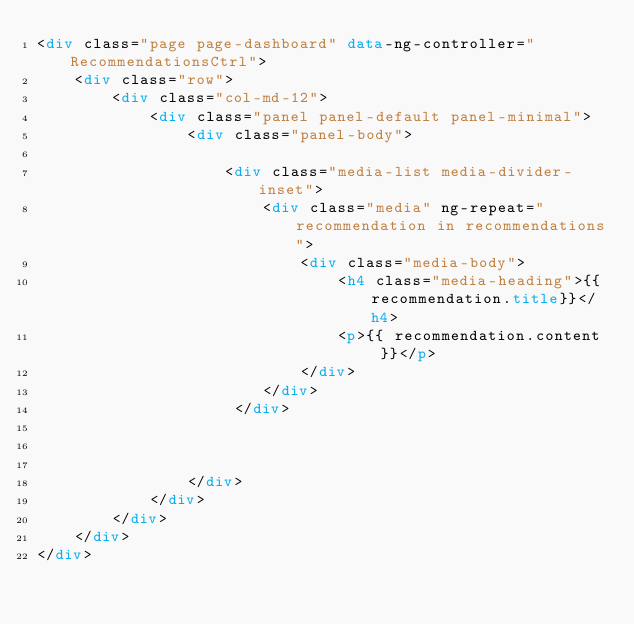<code> <loc_0><loc_0><loc_500><loc_500><_HTML_><div class="page page-dashboard" data-ng-controller="RecommendationsCtrl">
    <div class="row">
        <div class="col-md-12">
            <div class="panel panel-default panel-minimal">                
                <div class="panel-body">
         			
                    <div class="media-list media-divider-inset">
                        <div class="media" ng-repeat="recommendation in recommendations">
                            <div class="media-body">
                                <h4 class="media-heading">{{recommendation.title}}</h4>
                                <p>{{ recommendation.content }}</p>
                            </div>
                        </div>
                     </div>


                    
                </div>
            </div>
        </div>
    </div>
</div>
    </code> 